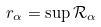<formula> <loc_0><loc_0><loc_500><loc_500>r _ { \alpha } = \sup \mathcal { R } _ { \alpha }</formula> 